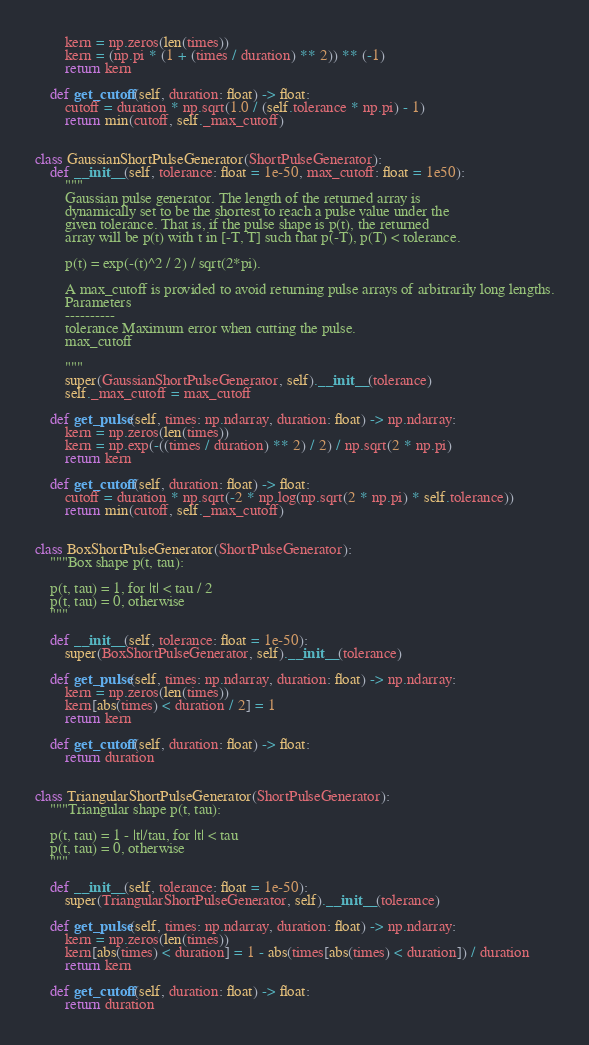Convert code to text. <code><loc_0><loc_0><loc_500><loc_500><_Python_>        kern = np.zeros(len(times))
        kern = (np.pi * (1 + (times / duration) ** 2)) ** (-1)
        return kern

    def get_cutoff(self, duration: float) -> float:
        cutoff = duration * np.sqrt(1.0 / (self.tolerance * np.pi) - 1)
        return min(cutoff, self._max_cutoff)


class GaussianShortPulseGenerator(ShortPulseGenerator):
    def __init__(self, tolerance: float = 1e-50, max_cutoff: float = 1e50):
        """
        Gaussian pulse generator. The length of the returned array is
        dynamically set to be the shortest to reach a pulse value under the
        given tolerance. That is, if the pulse shape is p(t), the returned
        array will be p(t) with t in [-T, T] such that p(-T), p(T) < tolerance.

        p(t) = exp(-(t)^2 / 2) / sqrt(2*pi).

        A max_cutoff is provided to avoid returning pulse arrays of arbitrarily long lengths.
        Parameters
        ----------
        tolerance Maximum error when cutting the pulse.
        max_cutoff

        """
        super(GaussianShortPulseGenerator, self).__init__(tolerance)
        self._max_cutoff = max_cutoff

    def get_pulse(self, times: np.ndarray, duration: float) -> np.ndarray:
        kern = np.zeros(len(times))
        kern = np.exp(-((times / duration) ** 2) / 2) / np.sqrt(2 * np.pi)
        return kern

    def get_cutoff(self, duration: float) -> float:
        cutoff = duration * np.sqrt(-2 * np.log(np.sqrt(2 * np.pi) * self.tolerance))
        return min(cutoff, self._max_cutoff)


class BoxShortPulseGenerator(ShortPulseGenerator):
    """Box shape p(t, tau):

    p(t, tau) = 1, for |t| < tau / 2
    p(t, tau) = 0, otherwise
    """

    def __init__(self, tolerance: float = 1e-50):
        super(BoxShortPulseGenerator, self).__init__(tolerance)

    def get_pulse(self, times: np.ndarray, duration: float) -> np.ndarray:
        kern = np.zeros(len(times))
        kern[abs(times) < duration / 2] = 1
        return kern

    def get_cutoff(self, duration: float) -> float:
        return duration


class TriangularShortPulseGenerator(ShortPulseGenerator):
    """Triangular shape p(t, tau):

    p(t, tau) = 1 - |t|/tau, for |t| < tau
    p(t, tau) = 0, otherwise
    """

    def __init__(self, tolerance: float = 1e-50):
        super(TriangularShortPulseGenerator, self).__init__(tolerance)

    def get_pulse(self, times: np.ndarray, duration: float) -> np.ndarray:
        kern = np.zeros(len(times))
        kern[abs(times) < duration] = 1 - abs(times[abs(times) < duration]) / duration
        return kern

    def get_cutoff(self, duration: float) -> float:
        return duration
</code> 